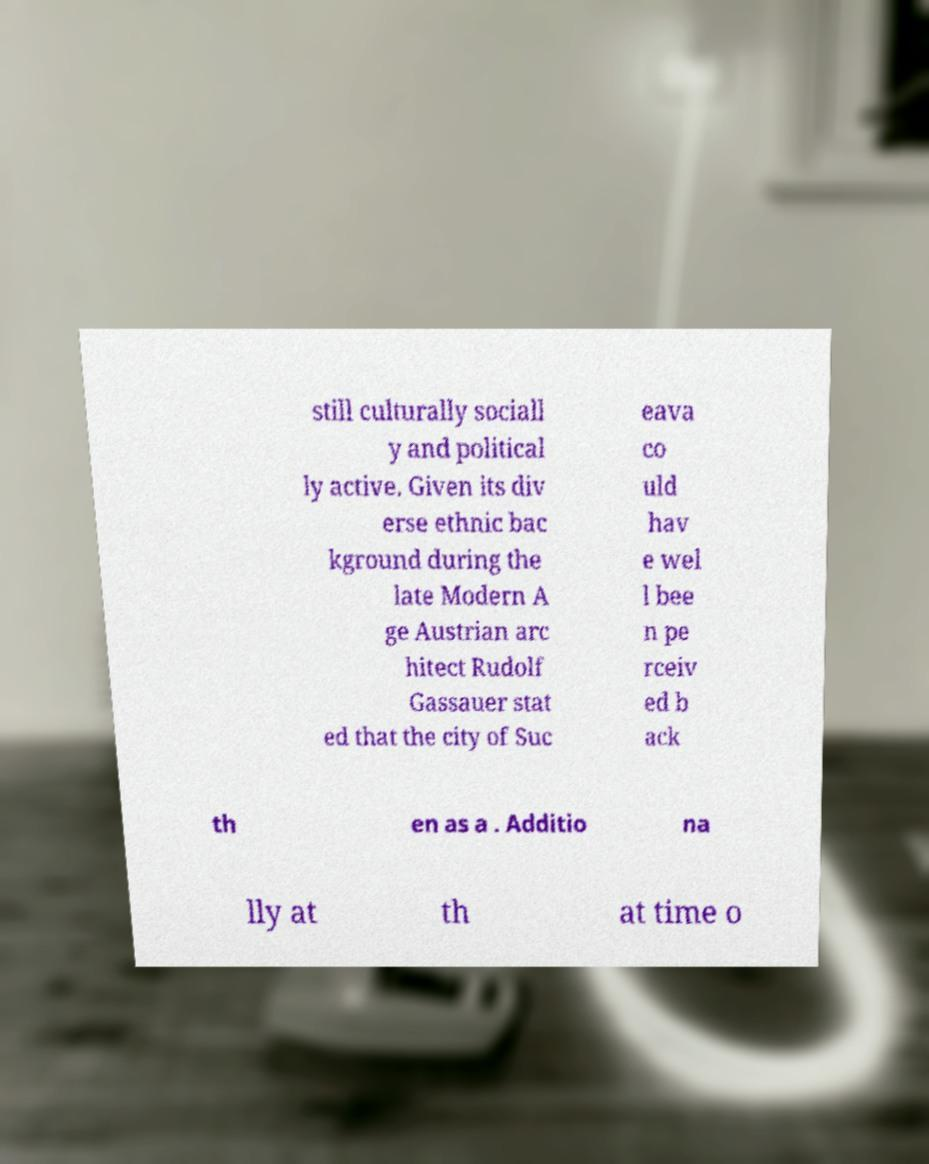What messages or text are displayed in this image? I need them in a readable, typed format. still culturally sociall y and political ly active. Given its div erse ethnic bac kground during the late Modern A ge Austrian arc hitect Rudolf Gassauer stat ed that the city of Suc eava co uld hav e wel l bee n pe rceiv ed b ack th en as a . Additio na lly at th at time o 